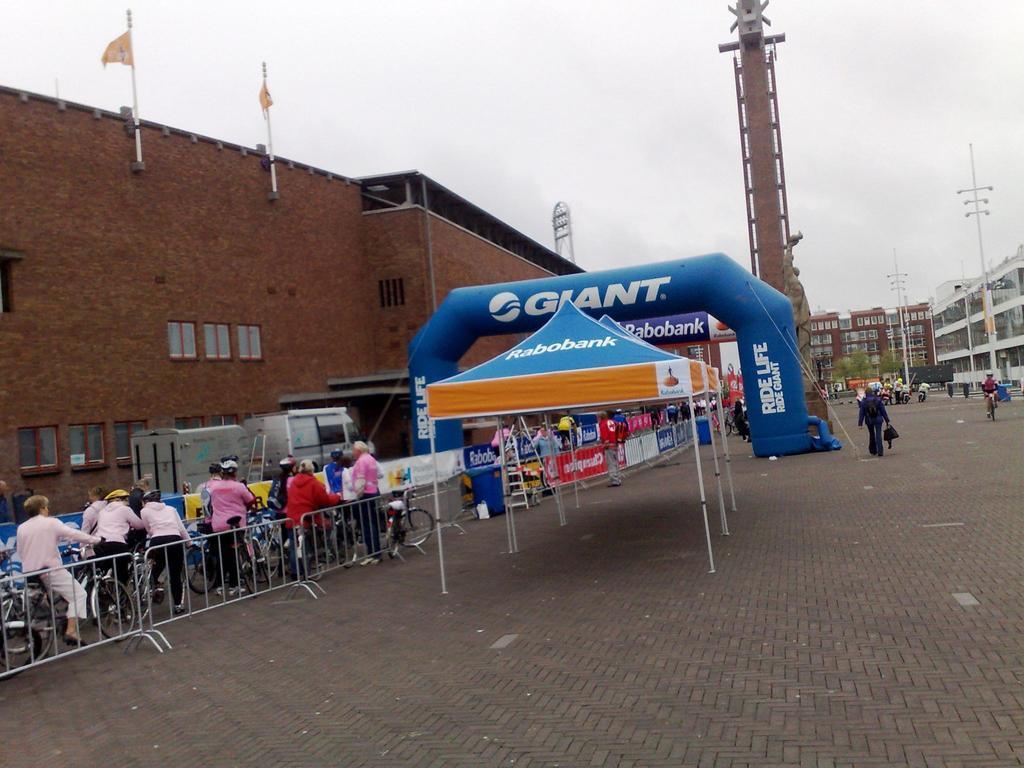How would you summarize this image in a sentence or two? In this image we can see the people on the road. And we can see the buildings, windows. And we can see the flags. And we can see the tent, statue. And we can see the metal fencing. And we can see the lights. And we can see the sky. 